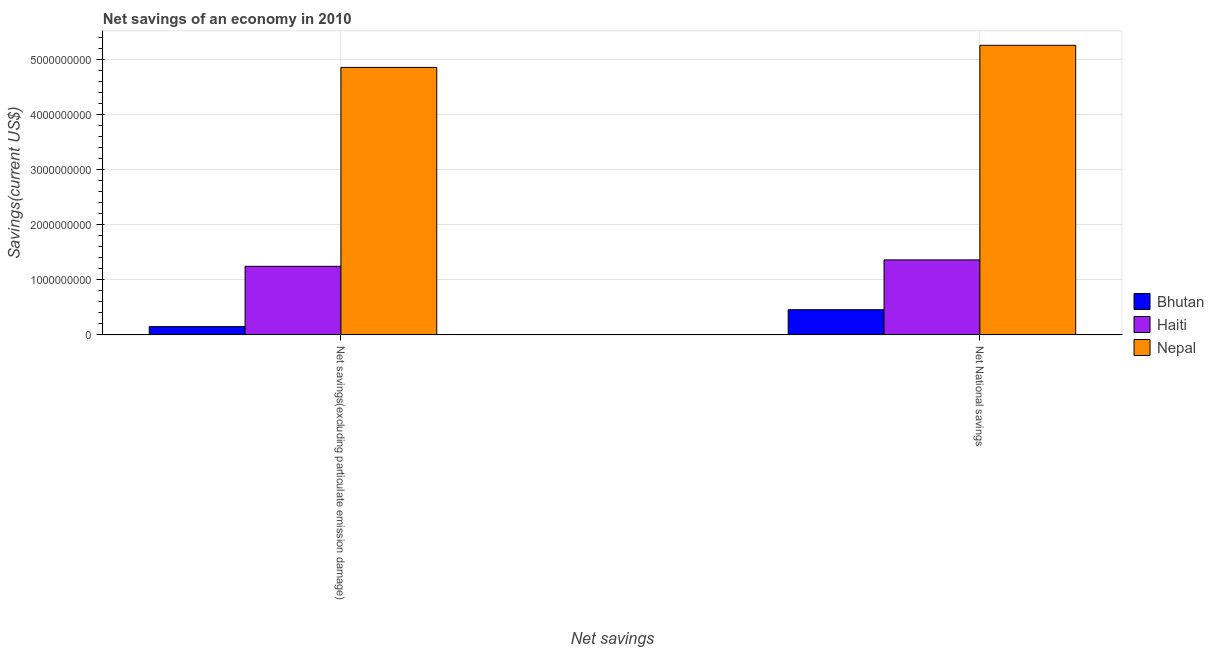How many different coloured bars are there?
Keep it short and to the point. 3. How many groups of bars are there?
Offer a very short reply. 2. Are the number of bars per tick equal to the number of legend labels?
Your answer should be compact. Yes. How many bars are there on the 1st tick from the left?
Offer a very short reply. 3. How many bars are there on the 1st tick from the right?
Your answer should be very brief. 3. What is the label of the 2nd group of bars from the left?
Provide a short and direct response. Net National savings. What is the net savings(excluding particulate emission damage) in Bhutan?
Provide a succinct answer. 1.50e+08. Across all countries, what is the maximum net national savings?
Give a very brief answer. 5.25e+09. Across all countries, what is the minimum net savings(excluding particulate emission damage)?
Your answer should be compact. 1.50e+08. In which country was the net national savings maximum?
Your answer should be compact. Nepal. In which country was the net national savings minimum?
Provide a short and direct response. Bhutan. What is the total net savings(excluding particulate emission damage) in the graph?
Provide a short and direct response. 6.25e+09. What is the difference between the net savings(excluding particulate emission damage) in Bhutan and that in Haiti?
Provide a succinct answer. -1.09e+09. What is the difference between the net savings(excluding particulate emission damage) in Bhutan and the net national savings in Haiti?
Make the answer very short. -1.21e+09. What is the average net savings(excluding particulate emission damage) per country?
Provide a succinct answer. 2.08e+09. What is the difference between the net national savings and net savings(excluding particulate emission damage) in Bhutan?
Provide a succinct answer. 3.06e+08. What is the ratio of the net national savings in Haiti to that in Bhutan?
Your response must be concise. 2.98. Is the net savings(excluding particulate emission damage) in Nepal less than that in Bhutan?
Your answer should be compact. No. What does the 2nd bar from the left in Net National savings represents?
Provide a succinct answer. Haiti. What does the 1st bar from the right in Net savings(excluding particulate emission damage) represents?
Offer a very short reply. Nepal. How many countries are there in the graph?
Keep it short and to the point. 3. Does the graph contain any zero values?
Your response must be concise. No. Where does the legend appear in the graph?
Your answer should be very brief. Center right. What is the title of the graph?
Offer a terse response. Net savings of an economy in 2010. What is the label or title of the X-axis?
Make the answer very short. Net savings. What is the label or title of the Y-axis?
Give a very brief answer. Savings(current US$). What is the Savings(current US$) in Bhutan in Net savings(excluding particulate emission damage)?
Your answer should be compact. 1.50e+08. What is the Savings(current US$) in Haiti in Net savings(excluding particulate emission damage)?
Offer a terse response. 1.24e+09. What is the Savings(current US$) in Nepal in Net savings(excluding particulate emission damage)?
Ensure brevity in your answer.  4.85e+09. What is the Savings(current US$) in Bhutan in Net National savings?
Your answer should be compact. 4.57e+08. What is the Savings(current US$) in Haiti in Net National savings?
Your response must be concise. 1.36e+09. What is the Savings(current US$) of Nepal in Net National savings?
Give a very brief answer. 5.25e+09. Across all Net savings, what is the maximum Savings(current US$) of Bhutan?
Offer a very short reply. 4.57e+08. Across all Net savings, what is the maximum Savings(current US$) of Haiti?
Provide a short and direct response. 1.36e+09. Across all Net savings, what is the maximum Savings(current US$) of Nepal?
Give a very brief answer. 5.25e+09. Across all Net savings, what is the minimum Savings(current US$) in Bhutan?
Offer a very short reply. 1.50e+08. Across all Net savings, what is the minimum Savings(current US$) of Haiti?
Your response must be concise. 1.24e+09. Across all Net savings, what is the minimum Savings(current US$) in Nepal?
Give a very brief answer. 4.85e+09. What is the total Savings(current US$) of Bhutan in the graph?
Provide a short and direct response. 6.07e+08. What is the total Savings(current US$) of Haiti in the graph?
Your response must be concise. 2.60e+09. What is the total Savings(current US$) in Nepal in the graph?
Give a very brief answer. 1.01e+1. What is the difference between the Savings(current US$) in Bhutan in Net savings(excluding particulate emission damage) and that in Net National savings?
Give a very brief answer. -3.06e+08. What is the difference between the Savings(current US$) in Haiti in Net savings(excluding particulate emission damage) and that in Net National savings?
Offer a terse response. -1.16e+08. What is the difference between the Savings(current US$) of Nepal in Net savings(excluding particulate emission damage) and that in Net National savings?
Your answer should be compact. -4.01e+08. What is the difference between the Savings(current US$) of Bhutan in Net savings(excluding particulate emission damage) and the Savings(current US$) of Haiti in Net National savings?
Your answer should be very brief. -1.21e+09. What is the difference between the Savings(current US$) in Bhutan in Net savings(excluding particulate emission damage) and the Savings(current US$) in Nepal in Net National savings?
Your answer should be compact. -5.10e+09. What is the difference between the Savings(current US$) in Haiti in Net savings(excluding particulate emission damage) and the Savings(current US$) in Nepal in Net National savings?
Provide a short and direct response. -4.01e+09. What is the average Savings(current US$) in Bhutan per Net savings?
Make the answer very short. 3.03e+08. What is the average Savings(current US$) of Haiti per Net savings?
Offer a terse response. 1.30e+09. What is the average Savings(current US$) in Nepal per Net savings?
Keep it short and to the point. 5.05e+09. What is the difference between the Savings(current US$) in Bhutan and Savings(current US$) in Haiti in Net savings(excluding particulate emission damage)?
Make the answer very short. -1.09e+09. What is the difference between the Savings(current US$) of Bhutan and Savings(current US$) of Nepal in Net savings(excluding particulate emission damage)?
Make the answer very short. -4.70e+09. What is the difference between the Savings(current US$) of Haiti and Savings(current US$) of Nepal in Net savings(excluding particulate emission damage)?
Keep it short and to the point. -3.61e+09. What is the difference between the Savings(current US$) of Bhutan and Savings(current US$) of Haiti in Net National savings?
Make the answer very short. -9.04e+08. What is the difference between the Savings(current US$) in Bhutan and Savings(current US$) in Nepal in Net National savings?
Keep it short and to the point. -4.80e+09. What is the difference between the Savings(current US$) of Haiti and Savings(current US$) of Nepal in Net National savings?
Your answer should be very brief. -3.89e+09. What is the ratio of the Savings(current US$) in Bhutan in Net savings(excluding particulate emission damage) to that in Net National savings?
Your response must be concise. 0.33. What is the ratio of the Savings(current US$) in Haiti in Net savings(excluding particulate emission damage) to that in Net National savings?
Provide a short and direct response. 0.91. What is the ratio of the Savings(current US$) in Nepal in Net savings(excluding particulate emission damage) to that in Net National savings?
Your answer should be very brief. 0.92. What is the difference between the highest and the second highest Savings(current US$) in Bhutan?
Offer a very short reply. 3.06e+08. What is the difference between the highest and the second highest Savings(current US$) in Haiti?
Make the answer very short. 1.16e+08. What is the difference between the highest and the second highest Savings(current US$) of Nepal?
Ensure brevity in your answer.  4.01e+08. What is the difference between the highest and the lowest Savings(current US$) of Bhutan?
Give a very brief answer. 3.06e+08. What is the difference between the highest and the lowest Savings(current US$) in Haiti?
Keep it short and to the point. 1.16e+08. What is the difference between the highest and the lowest Savings(current US$) in Nepal?
Provide a short and direct response. 4.01e+08. 